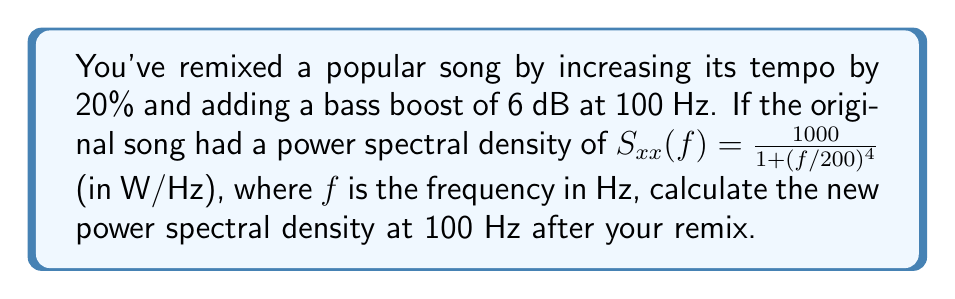Could you help me with this problem? Let's approach this step-by-step:

1) First, we need to account for the tempo increase. A 20% increase in tempo means that all frequencies will be shifted up by 20%. So, the new frequency corresponding to the original 100 Hz will be:

   $f_{new} = 100 \times 1.20 = 120$ Hz

2) Now, we need to calculate the original power spectral density at 120 Hz:

   $S_{xx}(120) = \frac{1000}{1 + (120/200)^4}$
   
   $= \frac{1000}{1 + (0.6)^4}$
   
   $= \frac{1000}{1 + 0.1296}$
   
   $= \frac{1000}{1.1296}$
   
   $\approx 885.09$ W/Hz

3) The bass boost of 6 dB at 100 Hz will affect this frequency. To convert dB to a linear scale, we use the formula:

   $\text{Linear factor} = 10^{(\text{dB}/10)}$

   $\text{Linear factor} = 10^{(6/10)} = 10^{0.6} \approx 3.9811$

4) Multiply the original power spectral density by this factor:

   $S_{xx}^{new}(100) = 885.09 \times 3.9811 \approx 3523.65$ W/Hz

Therefore, the new power spectral density at 100 Hz after the remix is approximately 3523.65 W/Hz.
Answer: $3523.65$ W/Hz 